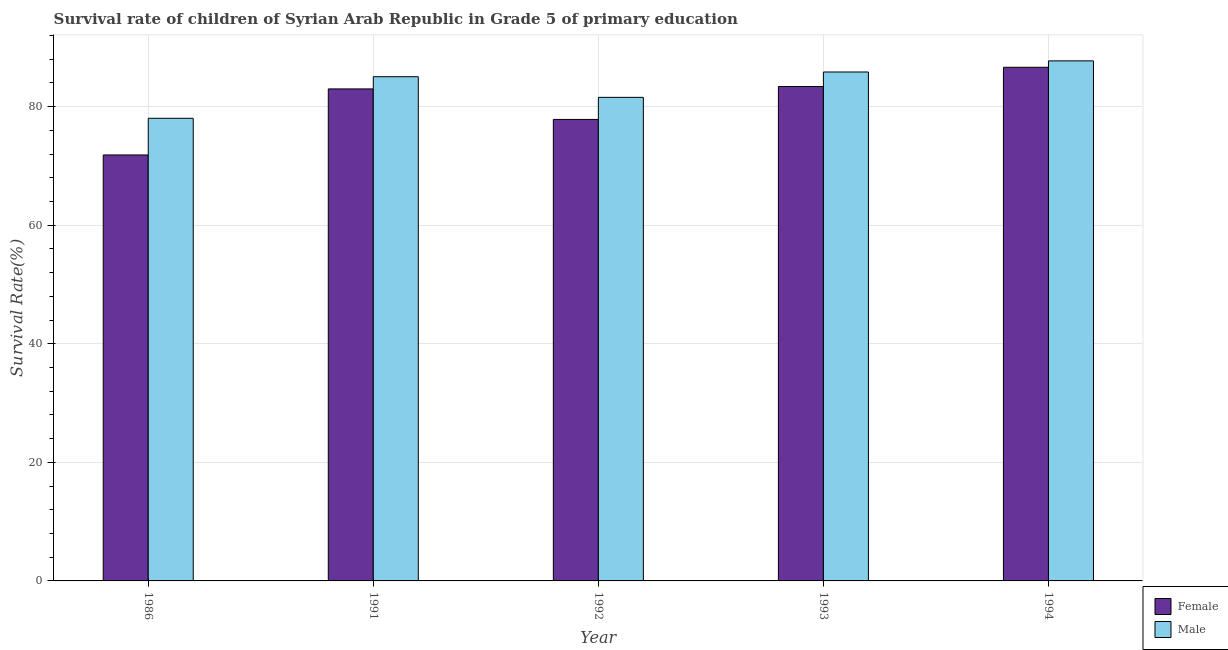How many different coloured bars are there?
Your answer should be very brief. 2. Are the number of bars on each tick of the X-axis equal?
Offer a very short reply. Yes. How many bars are there on the 2nd tick from the left?
Your response must be concise. 2. What is the survival rate of female students in primary education in 1994?
Give a very brief answer. 86.64. Across all years, what is the maximum survival rate of male students in primary education?
Provide a short and direct response. 87.72. Across all years, what is the minimum survival rate of female students in primary education?
Give a very brief answer. 71.85. In which year was the survival rate of female students in primary education minimum?
Make the answer very short. 1986. What is the total survival rate of female students in primary education in the graph?
Make the answer very short. 402.74. What is the difference between the survival rate of male students in primary education in 1986 and that in 1994?
Make the answer very short. -9.68. What is the difference between the survival rate of male students in primary education in 1994 and the survival rate of female students in primary education in 1986?
Make the answer very short. 9.68. What is the average survival rate of female students in primary education per year?
Provide a succinct answer. 80.55. In the year 1991, what is the difference between the survival rate of male students in primary education and survival rate of female students in primary education?
Your response must be concise. 0. In how many years, is the survival rate of female students in primary education greater than 36 %?
Keep it short and to the point. 5. What is the ratio of the survival rate of female students in primary education in 1991 to that in 1993?
Offer a very short reply. 1. Is the survival rate of male students in primary education in 1993 less than that in 1994?
Provide a short and direct response. Yes. Is the difference between the survival rate of male students in primary education in 1986 and 1991 greater than the difference between the survival rate of female students in primary education in 1986 and 1991?
Give a very brief answer. No. What is the difference between the highest and the second highest survival rate of male students in primary education?
Offer a terse response. 1.87. What is the difference between the highest and the lowest survival rate of female students in primary education?
Keep it short and to the point. 14.79. In how many years, is the survival rate of male students in primary education greater than the average survival rate of male students in primary education taken over all years?
Your response must be concise. 3. Is the sum of the survival rate of male students in primary education in 1992 and 1993 greater than the maximum survival rate of female students in primary education across all years?
Ensure brevity in your answer.  Yes. What does the 1st bar from the left in 1991 represents?
Keep it short and to the point. Female. How many bars are there?
Keep it short and to the point. 10. How many years are there in the graph?
Ensure brevity in your answer.  5. How many legend labels are there?
Your answer should be very brief. 2. How are the legend labels stacked?
Make the answer very short. Vertical. What is the title of the graph?
Your response must be concise. Survival rate of children of Syrian Arab Republic in Grade 5 of primary education. Does "Passenger Transport Items" appear as one of the legend labels in the graph?
Your answer should be compact. No. What is the label or title of the X-axis?
Provide a succinct answer. Year. What is the label or title of the Y-axis?
Offer a terse response. Survival Rate(%). What is the Survival Rate(%) of Female in 1986?
Provide a short and direct response. 71.85. What is the Survival Rate(%) of Male in 1986?
Your answer should be very brief. 78.04. What is the Survival Rate(%) in Female in 1991?
Your response must be concise. 82.99. What is the Survival Rate(%) of Male in 1991?
Provide a short and direct response. 85.05. What is the Survival Rate(%) in Female in 1992?
Offer a very short reply. 77.85. What is the Survival Rate(%) of Male in 1992?
Give a very brief answer. 81.57. What is the Survival Rate(%) in Female in 1993?
Provide a succinct answer. 83.4. What is the Survival Rate(%) of Male in 1993?
Provide a succinct answer. 85.85. What is the Survival Rate(%) of Female in 1994?
Offer a terse response. 86.64. What is the Survival Rate(%) in Male in 1994?
Offer a very short reply. 87.72. Across all years, what is the maximum Survival Rate(%) in Female?
Provide a short and direct response. 86.64. Across all years, what is the maximum Survival Rate(%) of Male?
Offer a very short reply. 87.72. Across all years, what is the minimum Survival Rate(%) of Female?
Your answer should be compact. 71.85. Across all years, what is the minimum Survival Rate(%) of Male?
Your answer should be compact. 78.04. What is the total Survival Rate(%) in Female in the graph?
Give a very brief answer. 402.74. What is the total Survival Rate(%) of Male in the graph?
Your answer should be very brief. 418.23. What is the difference between the Survival Rate(%) in Female in 1986 and that in 1991?
Give a very brief answer. -11.14. What is the difference between the Survival Rate(%) in Male in 1986 and that in 1991?
Ensure brevity in your answer.  -7.01. What is the difference between the Survival Rate(%) in Female in 1986 and that in 1992?
Provide a short and direct response. -5.99. What is the difference between the Survival Rate(%) in Male in 1986 and that in 1992?
Give a very brief answer. -3.53. What is the difference between the Survival Rate(%) in Female in 1986 and that in 1993?
Keep it short and to the point. -11.55. What is the difference between the Survival Rate(%) of Male in 1986 and that in 1993?
Your answer should be very brief. -7.81. What is the difference between the Survival Rate(%) in Female in 1986 and that in 1994?
Provide a succinct answer. -14.79. What is the difference between the Survival Rate(%) of Male in 1986 and that in 1994?
Make the answer very short. -9.68. What is the difference between the Survival Rate(%) in Female in 1991 and that in 1992?
Offer a very short reply. 5.15. What is the difference between the Survival Rate(%) in Male in 1991 and that in 1992?
Offer a terse response. 3.48. What is the difference between the Survival Rate(%) of Female in 1991 and that in 1993?
Give a very brief answer. -0.41. What is the difference between the Survival Rate(%) of Male in 1991 and that in 1993?
Your answer should be very brief. -0.8. What is the difference between the Survival Rate(%) of Female in 1991 and that in 1994?
Your response must be concise. -3.65. What is the difference between the Survival Rate(%) in Male in 1991 and that in 1994?
Your answer should be very brief. -2.67. What is the difference between the Survival Rate(%) of Female in 1992 and that in 1993?
Your response must be concise. -5.55. What is the difference between the Survival Rate(%) in Male in 1992 and that in 1993?
Offer a very short reply. -4.28. What is the difference between the Survival Rate(%) of Female in 1992 and that in 1994?
Offer a terse response. -8.8. What is the difference between the Survival Rate(%) of Male in 1992 and that in 1994?
Keep it short and to the point. -6.15. What is the difference between the Survival Rate(%) in Female in 1993 and that in 1994?
Offer a very short reply. -3.24. What is the difference between the Survival Rate(%) in Male in 1993 and that in 1994?
Your answer should be very brief. -1.87. What is the difference between the Survival Rate(%) in Female in 1986 and the Survival Rate(%) in Male in 1991?
Make the answer very short. -13.2. What is the difference between the Survival Rate(%) of Female in 1986 and the Survival Rate(%) of Male in 1992?
Your answer should be very brief. -9.71. What is the difference between the Survival Rate(%) in Female in 1986 and the Survival Rate(%) in Male in 1993?
Your answer should be compact. -13.99. What is the difference between the Survival Rate(%) of Female in 1986 and the Survival Rate(%) of Male in 1994?
Provide a short and direct response. -15.87. What is the difference between the Survival Rate(%) of Female in 1991 and the Survival Rate(%) of Male in 1992?
Keep it short and to the point. 1.42. What is the difference between the Survival Rate(%) in Female in 1991 and the Survival Rate(%) in Male in 1993?
Your answer should be compact. -2.86. What is the difference between the Survival Rate(%) of Female in 1991 and the Survival Rate(%) of Male in 1994?
Offer a very short reply. -4.73. What is the difference between the Survival Rate(%) in Female in 1992 and the Survival Rate(%) in Male in 1993?
Make the answer very short. -8. What is the difference between the Survival Rate(%) in Female in 1992 and the Survival Rate(%) in Male in 1994?
Your answer should be compact. -9.88. What is the difference between the Survival Rate(%) of Female in 1993 and the Survival Rate(%) of Male in 1994?
Provide a short and direct response. -4.32. What is the average Survival Rate(%) in Female per year?
Ensure brevity in your answer.  80.55. What is the average Survival Rate(%) in Male per year?
Offer a terse response. 83.65. In the year 1986, what is the difference between the Survival Rate(%) of Female and Survival Rate(%) of Male?
Keep it short and to the point. -6.18. In the year 1991, what is the difference between the Survival Rate(%) of Female and Survival Rate(%) of Male?
Offer a terse response. -2.06. In the year 1992, what is the difference between the Survival Rate(%) of Female and Survival Rate(%) of Male?
Your answer should be very brief. -3.72. In the year 1993, what is the difference between the Survival Rate(%) of Female and Survival Rate(%) of Male?
Provide a succinct answer. -2.45. In the year 1994, what is the difference between the Survival Rate(%) of Female and Survival Rate(%) of Male?
Keep it short and to the point. -1.08. What is the ratio of the Survival Rate(%) of Female in 1986 to that in 1991?
Keep it short and to the point. 0.87. What is the ratio of the Survival Rate(%) in Male in 1986 to that in 1991?
Provide a short and direct response. 0.92. What is the ratio of the Survival Rate(%) in Female in 1986 to that in 1992?
Your answer should be very brief. 0.92. What is the ratio of the Survival Rate(%) of Male in 1986 to that in 1992?
Offer a very short reply. 0.96. What is the ratio of the Survival Rate(%) in Female in 1986 to that in 1993?
Ensure brevity in your answer.  0.86. What is the ratio of the Survival Rate(%) in Male in 1986 to that in 1993?
Offer a very short reply. 0.91. What is the ratio of the Survival Rate(%) in Female in 1986 to that in 1994?
Provide a succinct answer. 0.83. What is the ratio of the Survival Rate(%) in Male in 1986 to that in 1994?
Your answer should be compact. 0.89. What is the ratio of the Survival Rate(%) of Female in 1991 to that in 1992?
Ensure brevity in your answer.  1.07. What is the ratio of the Survival Rate(%) in Male in 1991 to that in 1992?
Your answer should be very brief. 1.04. What is the ratio of the Survival Rate(%) in Female in 1991 to that in 1993?
Your answer should be compact. 1. What is the ratio of the Survival Rate(%) of Male in 1991 to that in 1993?
Your answer should be compact. 0.99. What is the ratio of the Survival Rate(%) of Female in 1991 to that in 1994?
Your answer should be compact. 0.96. What is the ratio of the Survival Rate(%) in Male in 1991 to that in 1994?
Provide a short and direct response. 0.97. What is the ratio of the Survival Rate(%) in Female in 1992 to that in 1993?
Your response must be concise. 0.93. What is the ratio of the Survival Rate(%) of Male in 1992 to that in 1993?
Ensure brevity in your answer.  0.95. What is the ratio of the Survival Rate(%) of Female in 1992 to that in 1994?
Keep it short and to the point. 0.9. What is the ratio of the Survival Rate(%) of Male in 1992 to that in 1994?
Offer a terse response. 0.93. What is the ratio of the Survival Rate(%) in Female in 1993 to that in 1994?
Offer a very short reply. 0.96. What is the ratio of the Survival Rate(%) in Male in 1993 to that in 1994?
Offer a very short reply. 0.98. What is the difference between the highest and the second highest Survival Rate(%) in Female?
Your response must be concise. 3.24. What is the difference between the highest and the second highest Survival Rate(%) of Male?
Offer a very short reply. 1.87. What is the difference between the highest and the lowest Survival Rate(%) in Female?
Provide a succinct answer. 14.79. What is the difference between the highest and the lowest Survival Rate(%) in Male?
Keep it short and to the point. 9.68. 